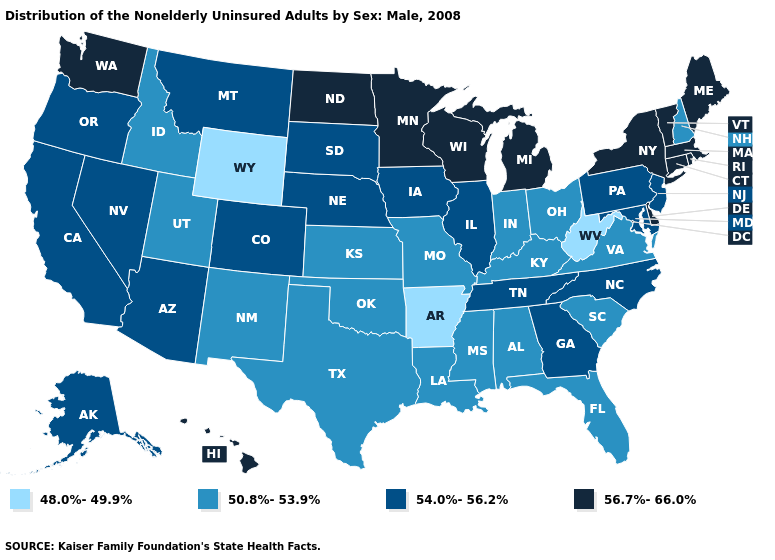What is the value of Wyoming?
Write a very short answer. 48.0%-49.9%. Name the states that have a value in the range 56.7%-66.0%?
Quick response, please. Connecticut, Delaware, Hawaii, Maine, Massachusetts, Michigan, Minnesota, New York, North Dakota, Rhode Island, Vermont, Washington, Wisconsin. What is the lowest value in the West?
Short answer required. 48.0%-49.9%. Which states hav the highest value in the West?
Give a very brief answer. Hawaii, Washington. Among the states that border Illinois , does Iowa have the lowest value?
Concise answer only. No. Does Pennsylvania have the highest value in the Northeast?
Keep it brief. No. What is the lowest value in the USA?
Write a very short answer. 48.0%-49.9%. What is the lowest value in the MidWest?
Quick response, please. 50.8%-53.9%. What is the highest value in the USA?
Short answer required. 56.7%-66.0%. Does Vermont have the highest value in the USA?
Keep it brief. Yes. What is the value of Oklahoma?
Quick response, please. 50.8%-53.9%. What is the value of Alaska?
Quick response, please. 54.0%-56.2%. Name the states that have a value in the range 54.0%-56.2%?
Short answer required. Alaska, Arizona, California, Colorado, Georgia, Illinois, Iowa, Maryland, Montana, Nebraska, Nevada, New Jersey, North Carolina, Oregon, Pennsylvania, South Dakota, Tennessee. Name the states that have a value in the range 50.8%-53.9%?
Write a very short answer. Alabama, Florida, Idaho, Indiana, Kansas, Kentucky, Louisiana, Mississippi, Missouri, New Hampshire, New Mexico, Ohio, Oklahoma, South Carolina, Texas, Utah, Virginia. Name the states that have a value in the range 48.0%-49.9%?
Answer briefly. Arkansas, West Virginia, Wyoming. 